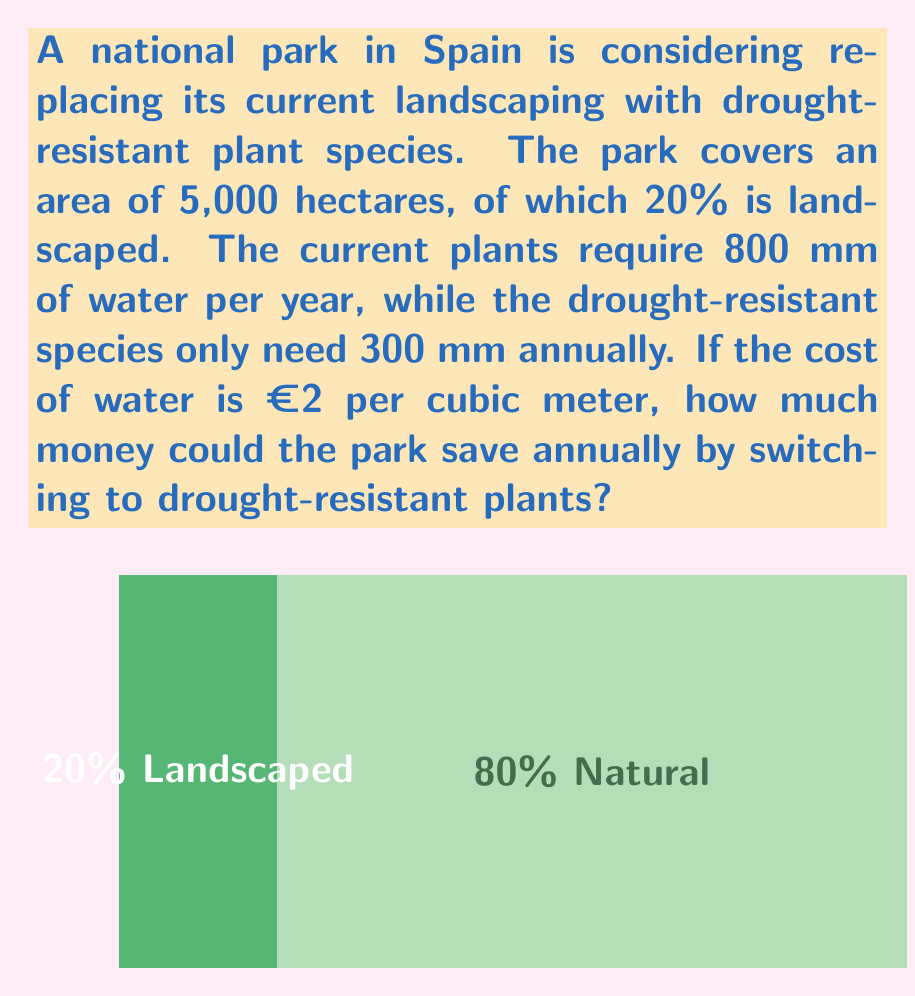Show me your answer to this math problem. Let's break this down step-by-step:

1) First, calculate the landscaped area:
   $20\% \text{ of } 5,000 \text{ hectares} = 0.2 \times 5,000 = 1,000 \text{ hectares}$

2) Convert hectares to square meters:
   $1,000 \text{ hectares} = 1,000 \times 10,000 = 10,000,000 \text{ m}^2$

3) Calculate the water savings per square meter:
   Current water usage: 800 mm = 0.8 m
   Drought-resistant usage: 300 mm = 0.3 m
   Water saved: $0.8 \text{ m} - 0.3 \text{ m} = 0.5 \text{ m}$

4) Calculate total water saved:
   $10,000,000 \text{ m}^2 \times 0.5 \text{ m} = 5,000,000 \text{ m}^3$

5) Calculate the cost savings:
   $5,000,000 \text{ m}^3 \times €2/\text{m}^3 = €10,000,000$

Therefore, the park could save €10 million annually by switching to drought-resistant plants.
Answer: €10,000,000 